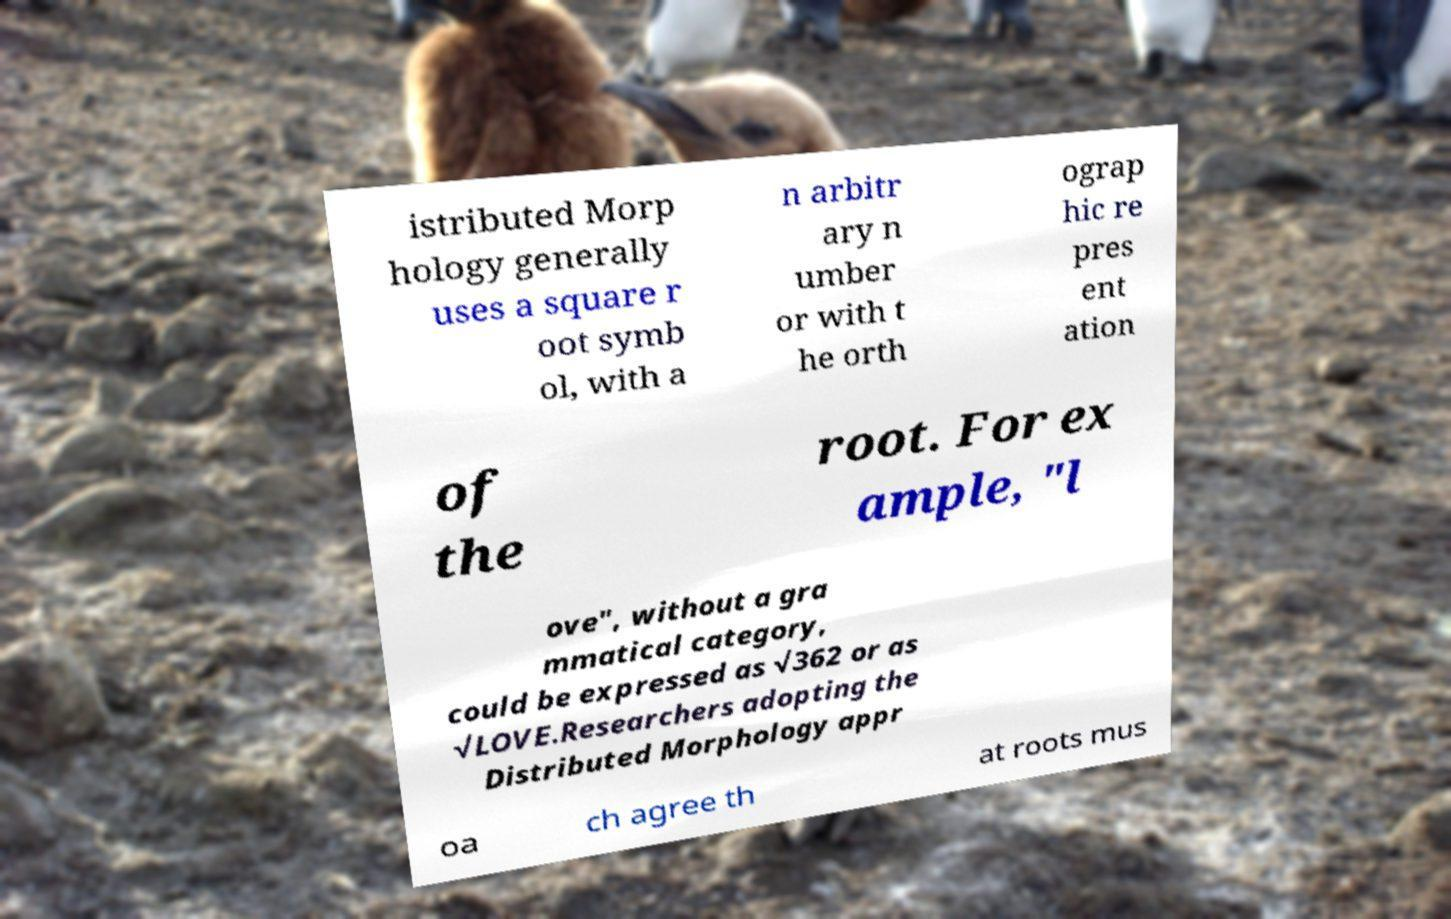Could you extract and type out the text from this image? istributed Morp hology generally uses a square r oot symb ol, with a n arbitr ary n umber or with t he orth ograp hic re pres ent ation of the root. For ex ample, "l ove", without a gra mmatical category, could be expressed as √362 or as √LOVE.Researchers adopting the Distributed Morphology appr oa ch agree th at roots mus 